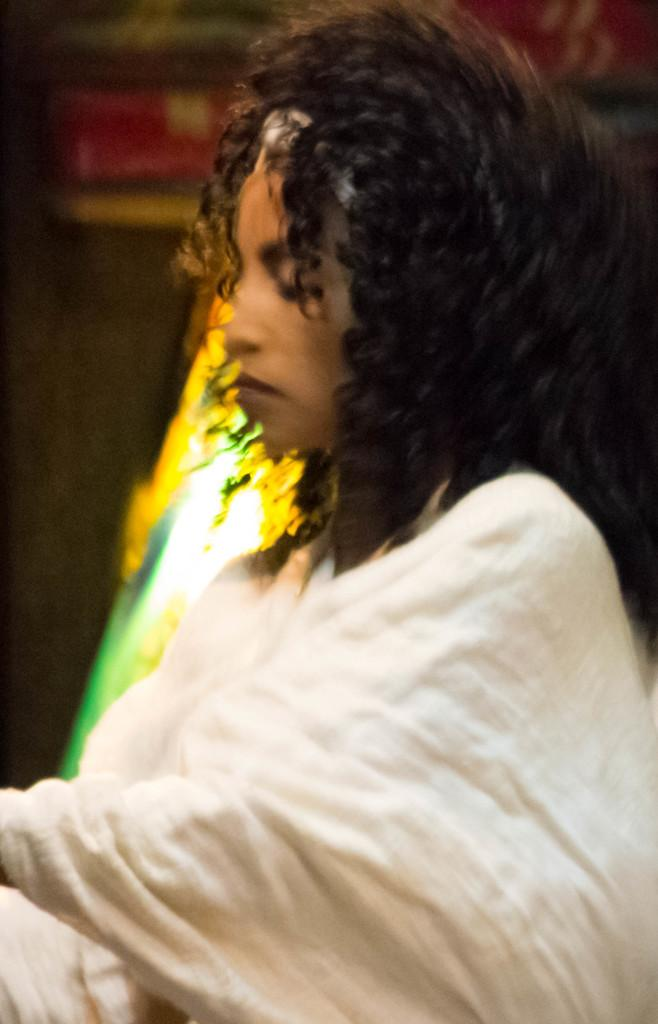Who is present in the image? There is a woman in the image. What can be seen in the background of the image? There is light in the background of the image. How is the light depicted in the image? The light appears blurry in the image. What type of vest is the woman wearing in the image? There is no vest visible in the image; the woman is not wearing any clothing that resembles a vest. 